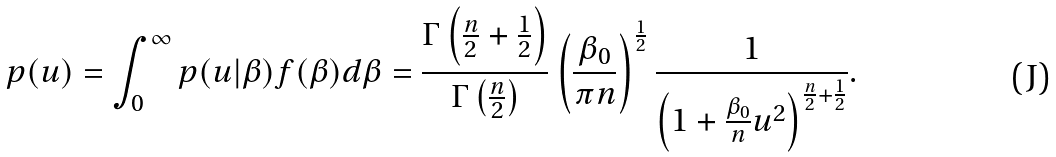<formula> <loc_0><loc_0><loc_500><loc_500>p ( u ) = \int _ { 0 } ^ { \infty } p ( u | \beta ) f ( \beta ) d \beta = \frac { \Gamma \left ( \frac { n } { 2 } + \frac { 1 } { 2 } \right ) } { \Gamma \left ( \frac { n } { 2 } \right ) } \left ( \frac { \beta _ { 0 } } { \pi n } \right ) ^ { \frac { 1 } { 2 } } \frac { 1 } { \left ( 1 + \frac { \beta _ { 0 } } { n } u ^ { 2 } \right ) ^ { \frac { n } { 2 } + \frac { 1 } { 2 } } } .</formula> 